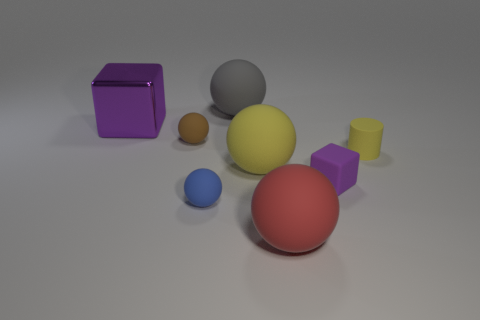Subtract all brown balls. How many balls are left? 4 Subtract all blue balls. How many balls are left? 4 Subtract all cyan spheres. Subtract all purple cylinders. How many spheres are left? 5 Add 2 tiny purple shiny cylinders. How many objects exist? 10 Subtract all blocks. How many objects are left? 6 Add 7 big purple metallic cubes. How many big purple metallic cubes are left? 8 Add 4 large metallic objects. How many large metallic objects exist? 5 Subtract 0 cyan cylinders. How many objects are left? 8 Subtract all small red matte balls. Subtract all tiny spheres. How many objects are left? 6 